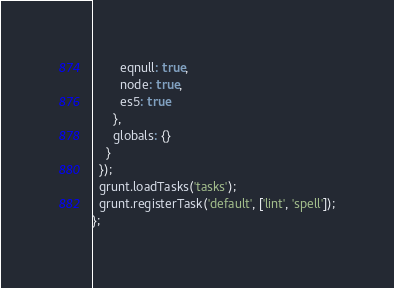<code> <loc_0><loc_0><loc_500><loc_500><_JavaScript_>        eqnull: true,
        node: true,
        es5: true
      },
      globals: {}
    }
  });
  grunt.loadTasks('tasks');
  grunt.registerTask('default', ['lint', 'spell']);
};
</code> 